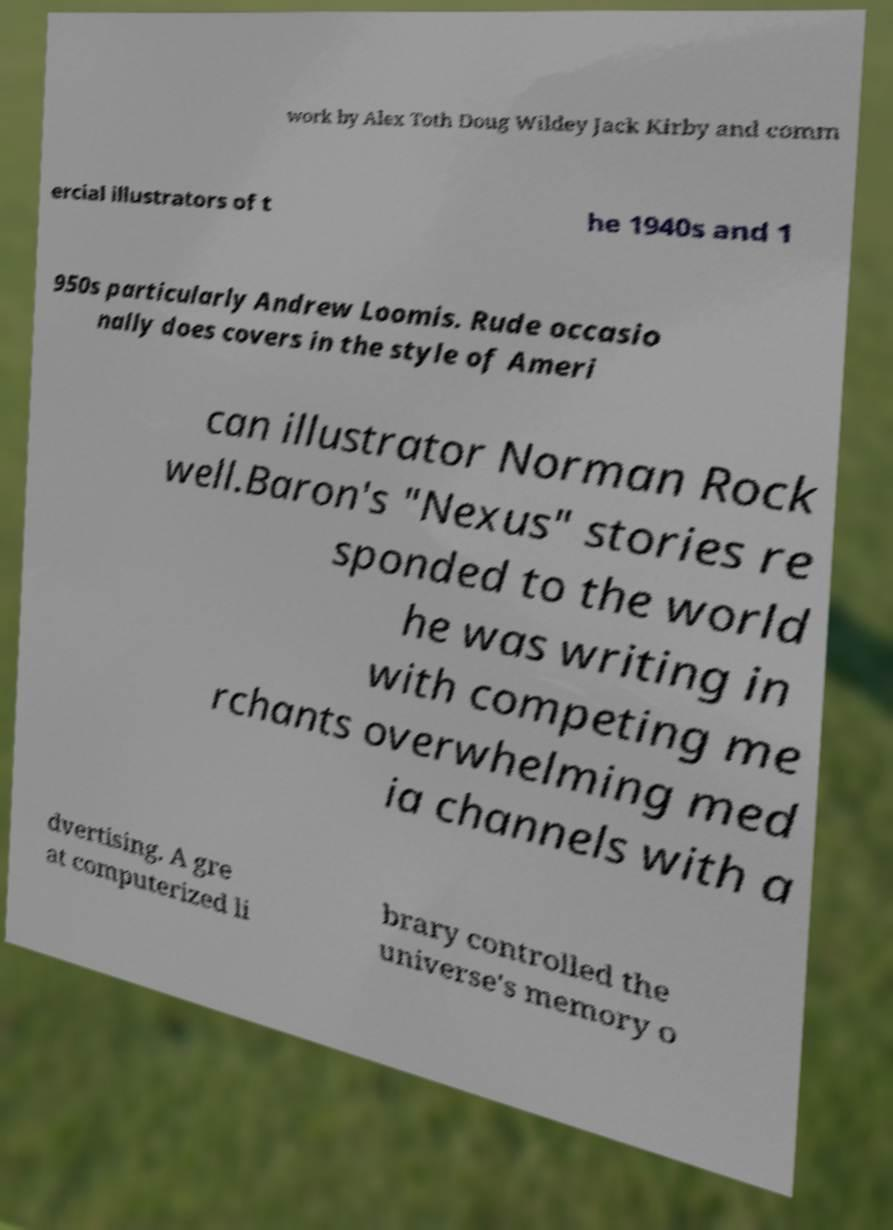Please identify and transcribe the text found in this image. work by Alex Toth Doug Wildey Jack Kirby and comm ercial illustrators of t he 1940s and 1 950s particularly Andrew Loomis. Rude occasio nally does covers in the style of Ameri can illustrator Norman Rock well.Baron's "Nexus" stories re sponded to the world he was writing in with competing me rchants overwhelming med ia channels with a dvertising. A gre at computerized li brary controlled the universe's memory o 